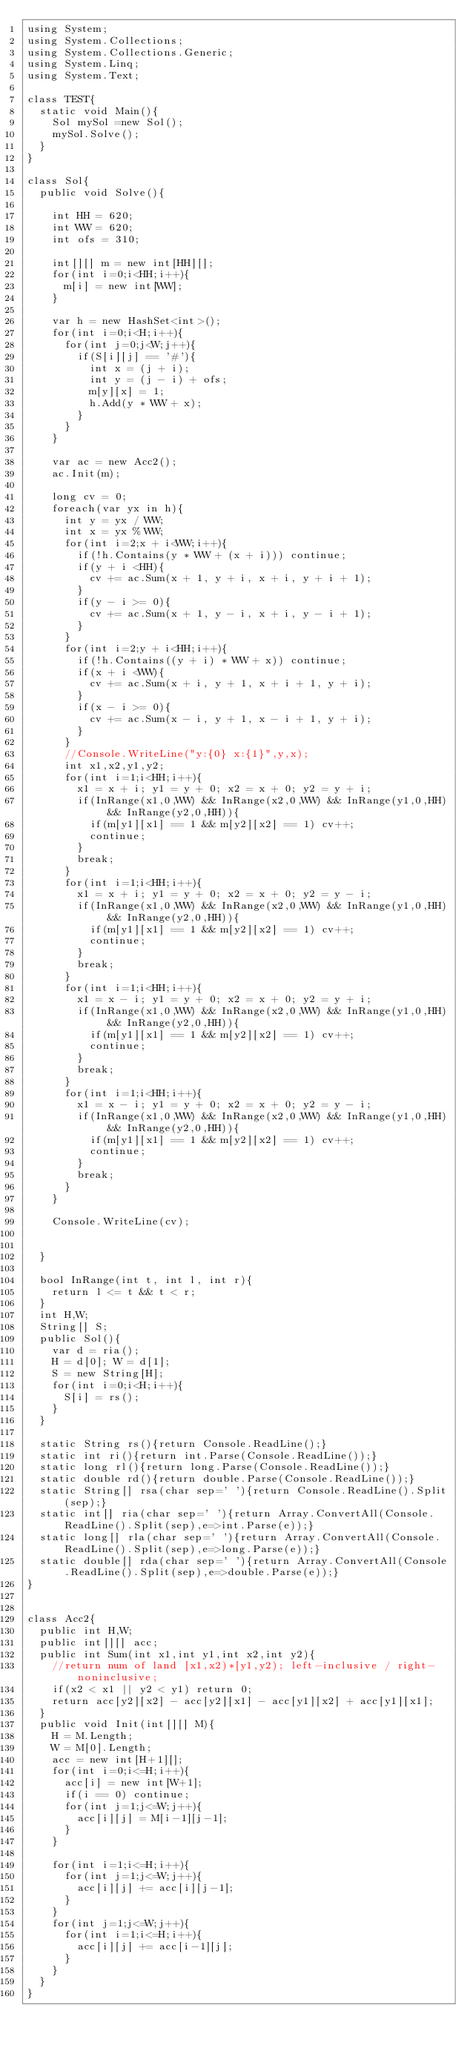<code> <loc_0><loc_0><loc_500><loc_500><_C#_>using System;
using System.Collections;
using System.Collections.Generic;
using System.Linq;
using System.Text;

class TEST{
	static void Main(){
		Sol mySol =new Sol();
		mySol.Solve();
	}
}

class Sol{
	public void Solve(){
		
		int HH = 620;
		int WW = 620;
		int ofs = 310;
		
		int[][] m = new int[HH][];
		for(int i=0;i<HH;i++){
			m[i] = new int[WW];
		}
		
		var h = new HashSet<int>();
		for(int i=0;i<H;i++){
			for(int j=0;j<W;j++){
				if(S[i][j] == '#'){
					int x = (j + i);
					int y = (j - i) + ofs;
					m[y][x] = 1;
					h.Add(y * WW + x);
				}
			}
		}
		
		var ac = new Acc2();
		ac.Init(m);
		
		long cv = 0;
		foreach(var yx in h){
			int y = yx / WW;
			int x = yx % WW;
			for(int i=2;x + i<WW;i++){
				if(!h.Contains(y * WW + (x + i))) continue;
				if(y + i <HH){
					cv += ac.Sum(x + 1, y + i, x + i, y + i + 1);
				}
				if(y - i >= 0){
					cv += ac.Sum(x + 1, y - i, x + i, y - i + 1);
				}
			}
			for(int i=2;y + i<HH;i++){
				if(!h.Contains((y + i) * WW + x)) continue;
				if(x + i <WW){
					cv += ac.Sum(x + i, y + 1, x + i + 1, y + i);
				}
				if(x - i >= 0){
					cv += ac.Sum(x - i, y + 1, x - i + 1, y + i);
				}
			}
			//Console.WriteLine("y:{0} x:{1}",y,x);
			int x1,x2,y1,y2;
			for(int i=1;i<HH;i++){
				x1 = x + i; y1 = y + 0; x2 = x + 0; y2 = y + i;
				if(InRange(x1,0,WW) && InRange(x2,0,WW) && InRange(y1,0,HH) && InRange(y2,0,HH)){
					if(m[y1][x1] == 1 && m[y2][x2] == 1) cv++;
					continue;
				}
				break;
			}
			for(int i=1;i<HH;i++){
				x1 = x + i; y1 = y + 0; x2 = x + 0; y2 = y - i;
				if(InRange(x1,0,WW) && InRange(x2,0,WW) && InRange(y1,0,HH) && InRange(y2,0,HH)){
					if(m[y1][x1] == 1 && m[y2][x2] == 1) cv++;
					continue;
				}
				break;
			}
			for(int i=1;i<HH;i++){
				x1 = x - i; y1 = y + 0; x2 = x + 0; y2 = y + i;
				if(InRange(x1,0,WW) && InRange(x2,0,WW) && InRange(y1,0,HH) && InRange(y2,0,HH)){
					if(m[y1][x1] == 1 && m[y2][x2] == 1) cv++;
					continue;
				}
				break;
			}
			for(int i=1;i<HH;i++){
				x1 = x - i; y1 = y + 0; x2 = x + 0; y2 = y - i;
				if(InRange(x1,0,WW) && InRange(x2,0,WW) && InRange(y1,0,HH) && InRange(y2,0,HH)){
					if(m[y1][x1] == 1 && m[y2][x2] == 1) cv++;
					continue;
				}
				break;
			}
		}
		
		Console.WriteLine(cv);
		
		
	}
	
	bool InRange(int t, int l, int r){
		return l <= t && t < r;
	}
	int H,W;
	String[] S;
	public Sol(){
		var d = ria();
		H = d[0]; W = d[1];
		S = new String[H];
		for(int i=0;i<H;i++){
			S[i] = rs();
		}
	}

	static String rs(){return Console.ReadLine();}
	static int ri(){return int.Parse(Console.ReadLine());}
	static long rl(){return long.Parse(Console.ReadLine());}
	static double rd(){return double.Parse(Console.ReadLine());}
	static String[] rsa(char sep=' '){return Console.ReadLine().Split(sep);}
	static int[] ria(char sep=' '){return Array.ConvertAll(Console.ReadLine().Split(sep),e=>int.Parse(e));}
	static long[] rla(char sep=' '){return Array.ConvertAll(Console.ReadLine().Split(sep),e=>long.Parse(e));}
	static double[] rda(char sep=' '){return Array.ConvertAll(Console.ReadLine().Split(sep),e=>double.Parse(e));}
}


class Acc2{
	public int H,W;
	public int[][] acc;
	public int Sum(int x1,int y1,int x2,int y2){
		//return num of land [x1,x2)*[y1,y2); left-inclusive / right-noninclusive;
		if(x2 < x1 || y2 < y1) return 0;
		return acc[y2][x2] - acc[y2][x1] - acc[y1][x2] + acc[y1][x1];
	}
	public void Init(int[][] M){
		H = M.Length;
		W = M[0].Length;
		acc = new int[H+1][];
		for(int i=0;i<=H;i++){
			acc[i] = new int[W+1];
			if(i == 0) continue;
			for(int j=1;j<=W;j++){
				acc[i][j] = M[i-1][j-1];
			}
		}
		
		for(int i=1;i<=H;i++){
			for(int j=1;j<=W;j++){
				acc[i][j] += acc[i][j-1];
			}
		}
		for(int j=1;j<=W;j++){
			for(int i=1;i<=H;i++){
				acc[i][j] += acc[i-1][j];
			}
		}
	}
}</code> 